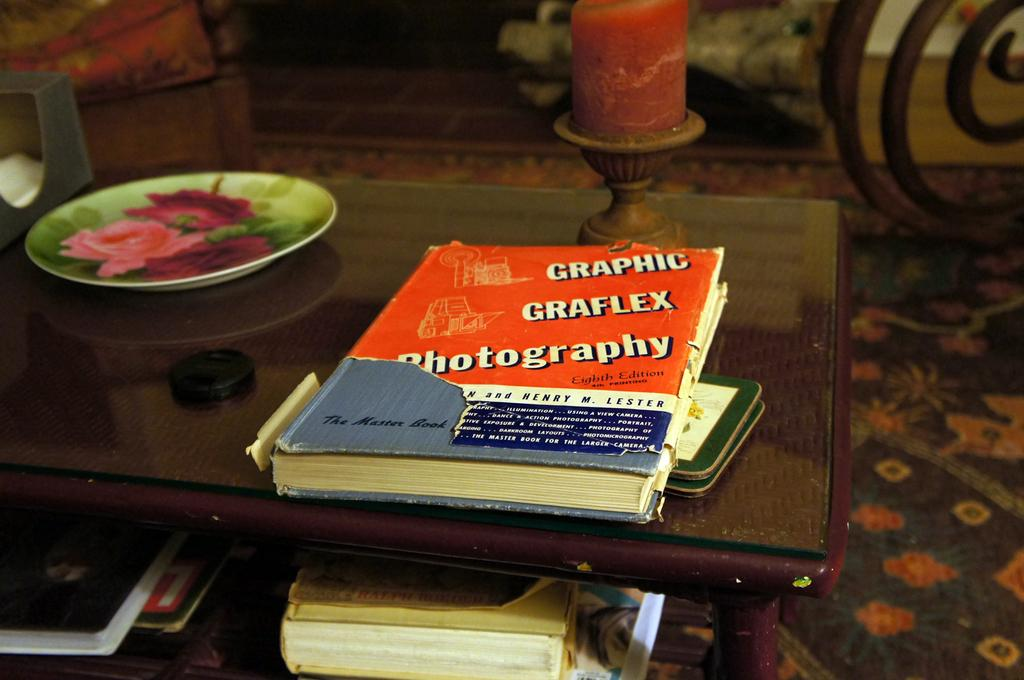Provide a one-sentence caption for the provided image. Books arranged on a coffee table include a tome on graphic photography how-to. 